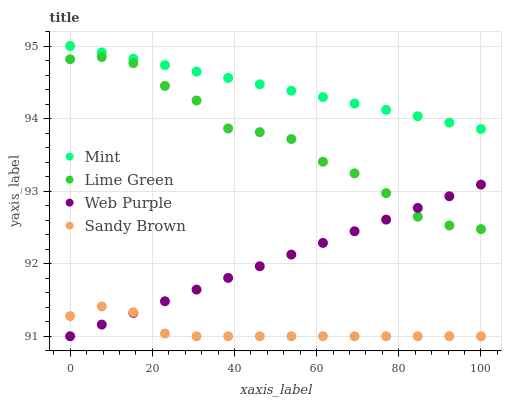Does Sandy Brown have the minimum area under the curve?
Answer yes or no. Yes. Does Mint have the maximum area under the curve?
Answer yes or no. Yes. Does Web Purple have the minimum area under the curve?
Answer yes or no. No. Does Web Purple have the maximum area under the curve?
Answer yes or no. No. Is Web Purple the smoothest?
Answer yes or no. Yes. Is Lime Green the roughest?
Answer yes or no. Yes. Is Mint the smoothest?
Answer yes or no. No. Is Mint the roughest?
Answer yes or no. No. Does Web Purple have the lowest value?
Answer yes or no. Yes. Does Mint have the lowest value?
Answer yes or no. No. Does Mint have the highest value?
Answer yes or no. Yes. Does Web Purple have the highest value?
Answer yes or no. No. Is Sandy Brown less than Mint?
Answer yes or no. Yes. Is Mint greater than Web Purple?
Answer yes or no. Yes. Does Lime Green intersect Web Purple?
Answer yes or no. Yes. Is Lime Green less than Web Purple?
Answer yes or no. No. Is Lime Green greater than Web Purple?
Answer yes or no. No. Does Sandy Brown intersect Mint?
Answer yes or no. No. 